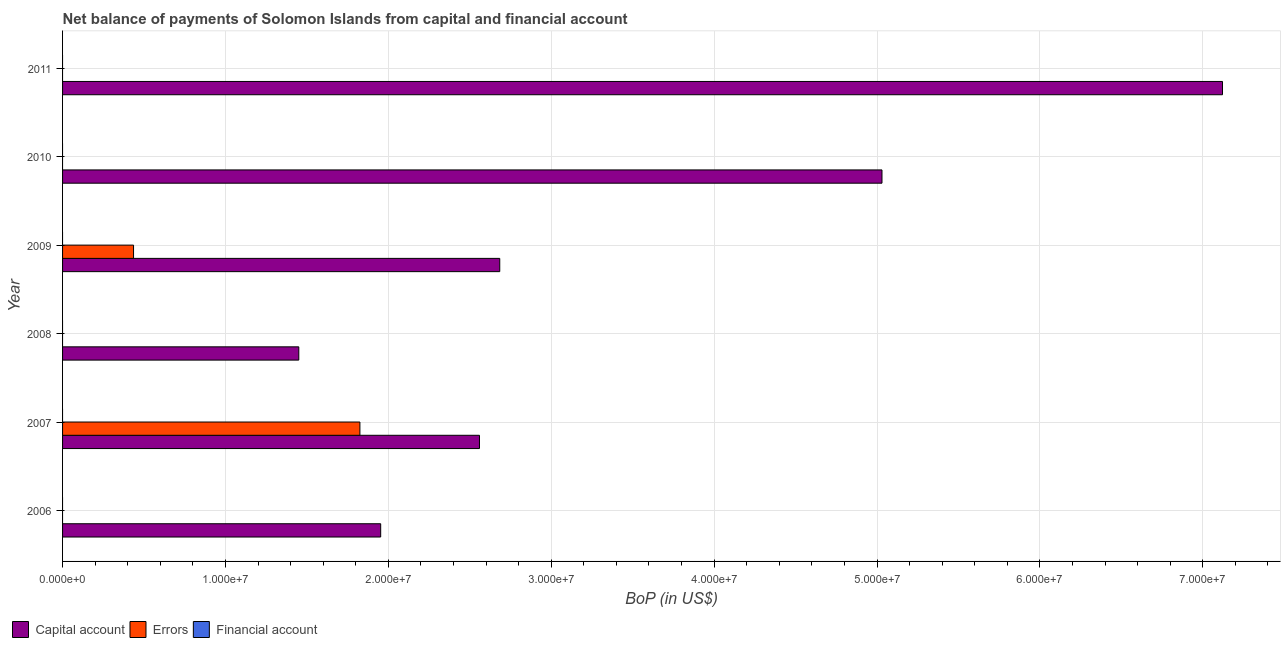How many bars are there on the 5th tick from the top?
Give a very brief answer. 2. Across all years, what is the maximum amount of net capital account?
Your response must be concise. 7.12e+07. Across all years, what is the minimum amount of errors?
Offer a very short reply. 0. What is the difference between the amount of net capital account in 2008 and that in 2009?
Provide a succinct answer. -1.23e+07. What is the difference between the amount of errors in 2006 and the amount of financial account in 2007?
Ensure brevity in your answer.  0. What is the average amount of financial account per year?
Your answer should be compact. 0. In the year 2007, what is the difference between the amount of errors and amount of net capital account?
Offer a very short reply. -7.34e+06. In how many years, is the amount of errors greater than 36000000 US$?
Give a very brief answer. 0. What is the ratio of the amount of net capital account in 2009 to that in 2011?
Your answer should be compact. 0.38. Is the amount of net capital account in 2009 less than that in 2011?
Your answer should be compact. Yes. What is the difference between the highest and the second highest amount of net capital account?
Your answer should be very brief. 2.09e+07. What is the difference between the highest and the lowest amount of net capital account?
Keep it short and to the point. 5.67e+07. In how many years, is the amount of financial account greater than the average amount of financial account taken over all years?
Ensure brevity in your answer.  0. Is the sum of the amount of net capital account in 2009 and 2011 greater than the maximum amount of financial account across all years?
Provide a succinct answer. Yes. How many bars are there?
Offer a very short reply. 8. Are all the bars in the graph horizontal?
Keep it short and to the point. Yes. How many years are there in the graph?
Your response must be concise. 6. What is the difference between two consecutive major ticks on the X-axis?
Offer a terse response. 1.00e+07. Are the values on the major ticks of X-axis written in scientific E-notation?
Your response must be concise. Yes. What is the title of the graph?
Offer a very short reply. Net balance of payments of Solomon Islands from capital and financial account. What is the label or title of the X-axis?
Make the answer very short. BoP (in US$). What is the BoP (in US$) of Capital account in 2006?
Your answer should be very brief. 1.95e+07. What is the BoP (in US$) of Capital account in 2007?
Your answer should be very brief. 2.56e+07. What is the BoP (in US$) in Errors in 2007?
Make the answer very short. 1.83e+07. What is the BoP (in US$) of Financial account in 2007?
Offer a terse response. 0. What is the BoP (in US$) of Capital account in 2008?
Ensure brevity in your answer.  1.45e+07. What is the BoP (in US$) in Capital account in 2009?
Make the answer very short. 2.68e+07. What is the BoP (in US$) in Errors in 2009?
Give a very brief answer. 4.36e+06. What is the BoP (in US$) of Capital account in 2010?
Give a very brief answer. 5.03e+07. What is the BoP (in US$) in Capital account in 2011?
Your answer should be compact. 7.12e+07. What is the BoP (in US$) of Errors in 2011?
Keep it short and to the point. 0. Across all years, what is the maximum BoP (in US$) of Capital account?
Provide a short and direct response. 7.12e+07. Across all years, what is the maximum BoP (in US$) in Errors?
Your answer should be compact. 1.83e+07. Across all years, what is the minimum BoP (in US$) in Capital account?
Keep it short and to the point. 1.45e+07. What is the total BoP (in US$) of Capital account in the graph?
Offer a very short reply. 2.08e+08. What is the total BoP (in US$) in Errors in the graph?
Give a very brief answer. 2.26e+07. What is the total BoP (in US$) in Financial account in the graph?
Provide a short and direct response. 0. What is the difference between the BoP (in US$) in Capital account in 2006 and that in 2007?
Your response must be concise. -6.06e+06. What is the difference between the BoP (in US$) of Capital account in 2006 and that in 2008?
Your answer should be very brief. 5.03e+06. What is the difference between the BoP (in US$) in Capital account in 2006 and that in 2009?
Offer a very short reply. -7.31e+06. What is the difference between the BoP (in US$) of Capital account in 2006 and that in 2010?
Provide a succinct answer. -3.08e+07. What is the difference between the BoP (in US$) in Capital account in 2006 and that in 2011?
Make the answer very short. -5.17e+07. What is the difference between the BoP (in US$) of Capital account in 2007 and that in 2008?
Your answer should be very brief. 1.11e+07. What is the difference between the BoP (in US$) in Capital account in 2007 and that in 2009?
Make the answer very short. -1.24e+06. What is the difference between the BoP (in US$) in Errors in 2007 and that in 2009?
Make the answer very short. 1.39e+07. What is the difference between the BoP (in US$) in Capital account in 2007 and that in 2010?
Offer a very short reply. -2.47e+07. What is the difference between the BoP (in US$) of Capital account in 2007 and that in 2011?
Ensure brevity in your answer.  -4.56e+07. What is the difference between the BoP (in US$) of Capital account in 2008 and that in 2009?
Offer a terse response. -1.23e+07. What is the difference between the BoP (in US$) in Capital account in 2008 and that in 2010?
Give a very brief answer. -3.58e+07. What is the difference between the BoP (in US$) of Capital account in 2008 and that in 2011?
Ensure brevity in your answer.  -5.67e+07. What is the difference between the BoP (in US$) of Capital account in 2009 and that in 2010?
Give a very brief answer. -2.35e+07. What is the difference between the BoP (in US$) in Capital account in 2009 and that in 2011?
Your answer should be very brief. -4.44e+07. What is the difference between the BoP (in US$) in Capital account in 2010 and that in 2011?
Offer a very short reply. -2.09e+07. What is the difference between the BoP (in US$) in Capital account in 2006 and the BoP (in US$) in Errors in 2007?
Offer a terse response. 1.28e+06. What is the difference between the BoP (in US$) of Capital account in 2006 and the BoP (in US$) of Errors in 2009?
Your answer should be compact. 1.52e+07. What is the difference between the BoP (in US$) of Capital account in 2007 and the BoP (in US$) of Errors in 2009?
Make the answer very short. 2.12e+07. What is the difference between the BoP (in US$) in Capital account in 2008 and the BoP (in US$) in Errors in 2009?
Your answer should be compact. 1.01e+07. What is the average BoP (in US$) in Capital account per year?
Your response must be concise. 3.47e+07. What is the average BoP (in US$) of Errors per year?
Your answer should be compact. 3.77e+06. What is the average BoP (in US$) of Financial account per year?
Offer a terse response. 0. In the year 2007, what is the difference between the BoP (in US$) in Capital account and BoP (in US$) in Errors?
Offer a terse response. 7.34e+06. In the year 2009, what is the difference between the BoP (in US$) of Capital account and BoP (in US$) of Errors?
Make the answer very short. 2.25e+07. What is the ratio of the BoP (in US$) of Capital account in 2006 to that in 2007?
Your response must be concise. 0.76. What is the ratio of the BoP (in US$) in Capital account in 2006 to that in 2008?
Give a very brief answer. 1.35. What is the ratio of the BoP (in US$) of Capital account in 2006 to that in 2009?
Make the answer very short. 0.73. What is the ratio of the BoP (in US$) in Capital account in 2006 to that in 2010?
Your response must be concise. 0.39. What is the ratio of the BoP (in US$) in Capital account in 2006 to that in 2011?
Your answer should be very brief. 0.27. What is the ratio of the BoP (in US$) in Capital account in 2007 to that in 2008?
Your response must be concise. 1.76. What is the ratio of the BoP (in US$) in Capital account in 2007 to that in 2009?
Provide a succinct answer. 0.95. What is the ratio of the BoP (in US$) in Errors in 2007 to that in 2009?
Your answer should be compact. 4.19. What is the ratio of the BoP (in US$) of Capital account in 2007 to that in 2010?
Give a very brief answer. 0.51. What is the ratio of the BoP (in US$) in Capital account in 2007 to that in 2011?
Your response must be concise. 0.36. What is the ratio of the BoP (in US$) of Capital account in 2008 to that in 2009?
Provide a succinct answer. 0.54. What is the ratio of the BoP (in US$) in Capital account in 2008 to that in 2010?
Offer a very short reply. 0.29. What is the ratio of the BoP (in US$) of Capital account in 2008 to that in 2011?
Keep it short and to the point. 0.2. What is the ratio of the BoP (in US$) of Capital account in 2009 to that in 2010?
Give a very brief answer. 0.53. What is the ratio of the BoP (in US$) in Capital account in 2009 to that in 2011?
Offer a terse response. 0.38. What is the ratio of the BoP (in US$) of Capital account in 2010 to that in 2011?
Provide a succinct answer. 0.71. What is the difference between the highest and the second highest BoP (in US$) of Capital account?
Offer a terse response. 2.09e+07. What is the difference between the highest and the lowest BoP (in US$) of Capital account?
Provide a succinct answer. 5.67e+07. What is the difference between the highest and the lowest BoP (in US$) of Errors?
Your answer should be compact. 1.83e+07. 